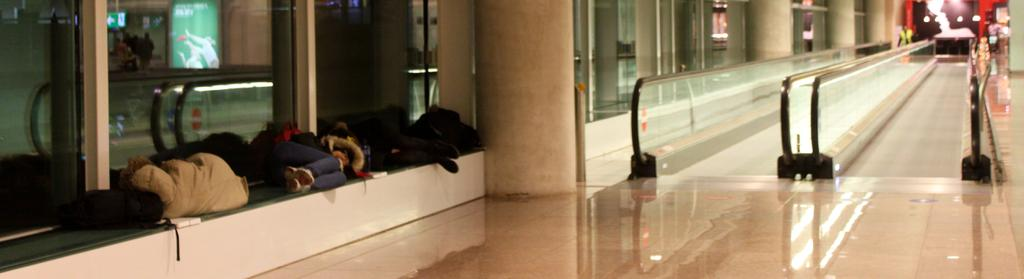Where was the image taken? The image was taken at an airport. What can be seen in the foreground of the image? There are people sitting on a bench in the image. What is visible in the background of the image? There are two straight escalators in the background of the image. What type of hill can be seen in the background of the image? There is no hill present in the image; it was taken at an airport, and the background features escalators. 